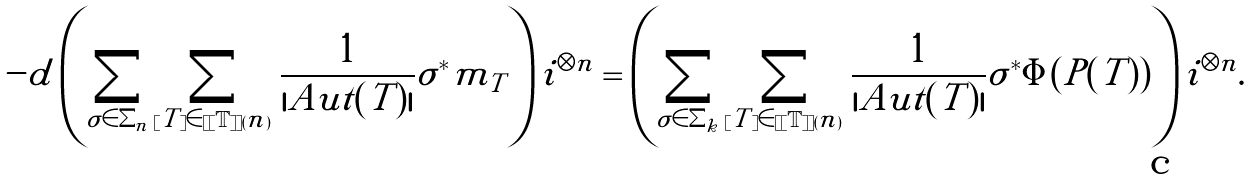<formula> <loc_0><loc_0><loc_500><loc_500>- d \left ( \sum _ { \sigma \in \Sigma _ { n } } \sum _ { [ T ] \in [ [ \mathbb { T } ] ] ( n ) } \frac { 1 } { | A u t ( T ) | } \sigma ^ { * } \tilde { m } _ { T } \right ) i ^ { \otimes n } = \left ( \sum _ { \sigma \in \Sigma _ { k } } \sum _ { [ T ] \in [ [ \mathbb { T } ] ] ( n ) } \frac { 1 } { | A u t ( T ) | } \sigma ^ { * } \Phi ( P ( T ) ) \right ) i ^ { \otimes n } .</formula> 